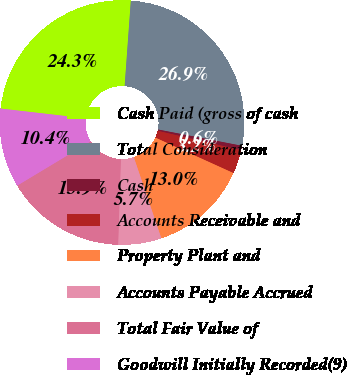<chart> <loc_0><loc_0><loc_500><loc_500><pie_chart><fcel>Cash Paid (gross of cash<fcel>Total Consideration<fcel>Cash<fcel>Accounts Receivable and<fcel>Property Plant and<fcel>Accounts Payable Accrued<fcel>Total Fair Value of<fcel>Goodwill Initially Recorded(9)<nl><fcel>24.33%<fcel>26.9%<fcel>0.58%<fcel>3.15%<fcel>13.01%<fcel>5.72%<fcel>15.87%<fcel>10.44%<nl></chart> 